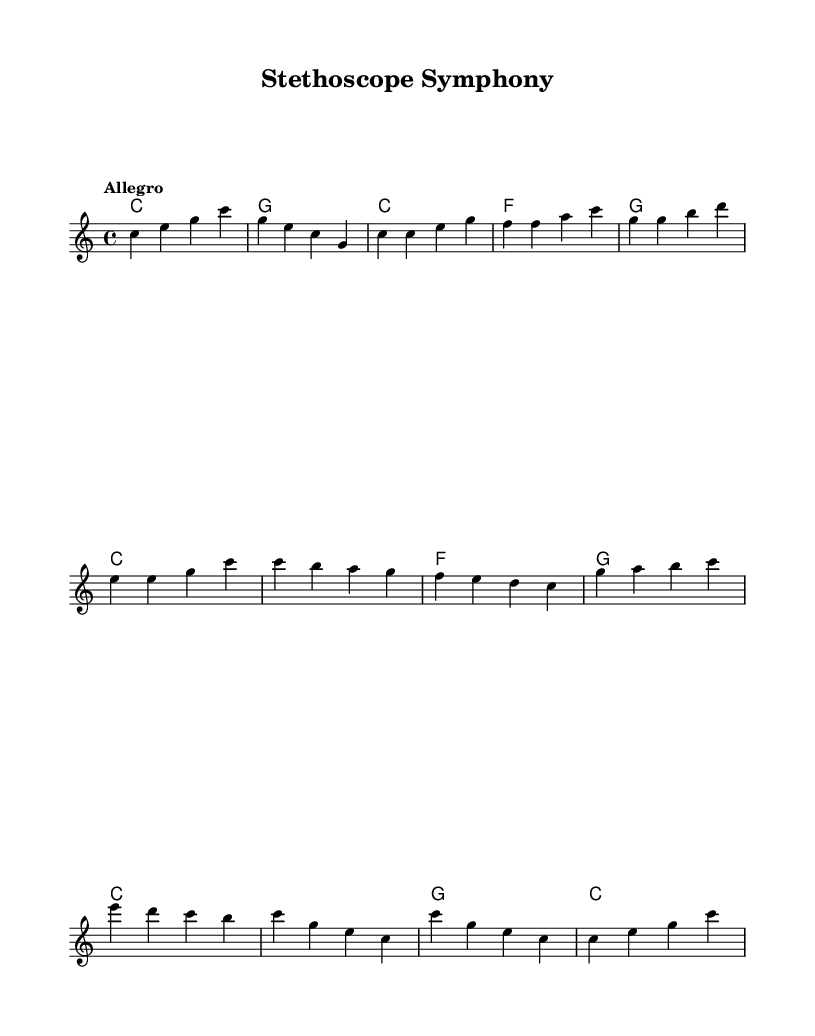What is the key signature of this music? The key signature is C major, which has no sharps or flats.
Answer: C major What is the time signature of this music? The time signature is 4/4, indicating four beats per measure.
Answer: 4/4 What is the tempo marking of this piece? The tempo marking is "Allegro," which indicates a fast and lively pace.
Answer: Allegro How many measures are there in the chorus section? The chorus section consists of four measures, as indicated by the notation in that part of the music.
Answer: 4 Which chords are used in the intro? The chords used in the intro are C and G, as shown in the chord mode for that section.
Answer: C, G What is the final chord of the piece? The final chord is C, as presented in the outro, which resolves the piece harmonically.
Answer: C How does the melody primarily move in the chorus? The melody primarily moves stepwise and includes a descending pattern, creating a dynamic feel during the chorus.
Answer: Descending pattern 